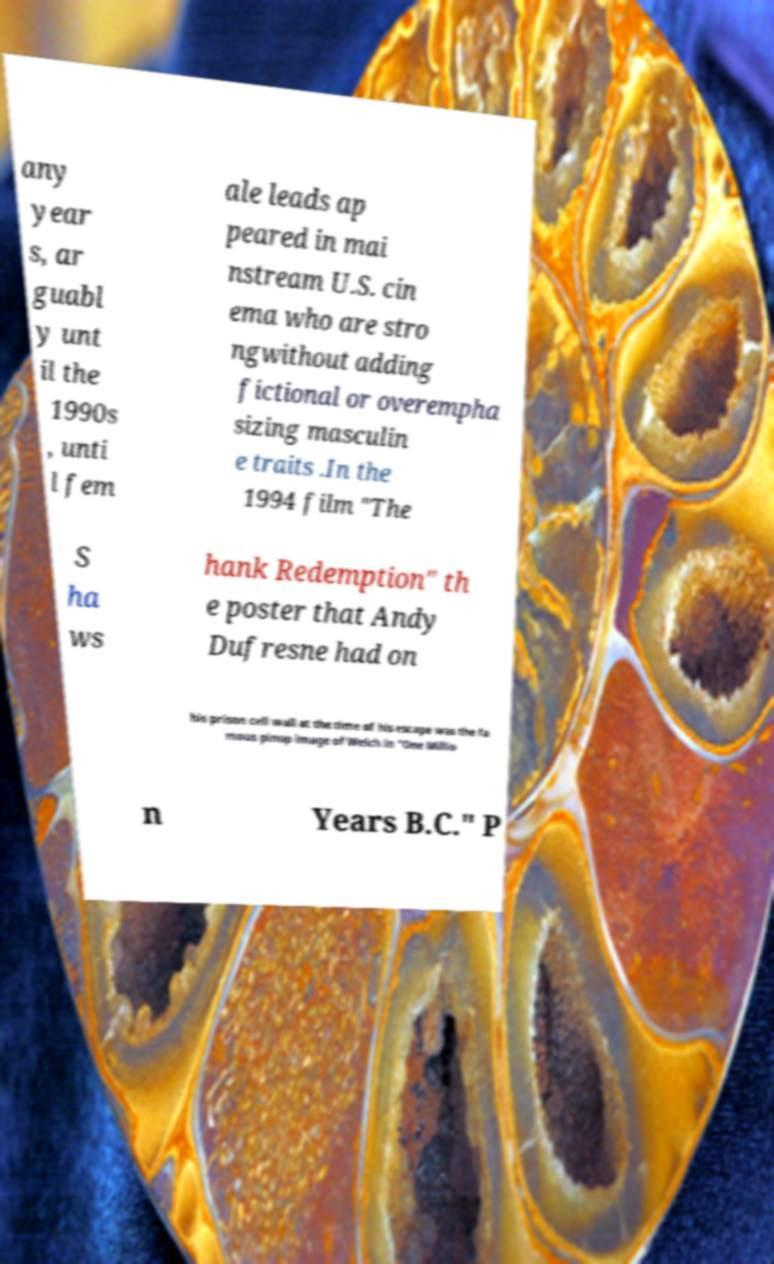I need the written content from this picture converted into text. Can you do that? any year s, ar guabl y unt il the 1990s , unti l fem ale leads ap peared in mai nstream U.S. cin ema who are stro ngwithout adding fictional or overempha sizing masculin e traits .In the 1994 film "The S ha ws hank Redemption" th e poster that Andy Dufresne had on his prison cell wall at the time of his escape was the fa mous pinup image of Welch in "One Millio n Years B.C." P 